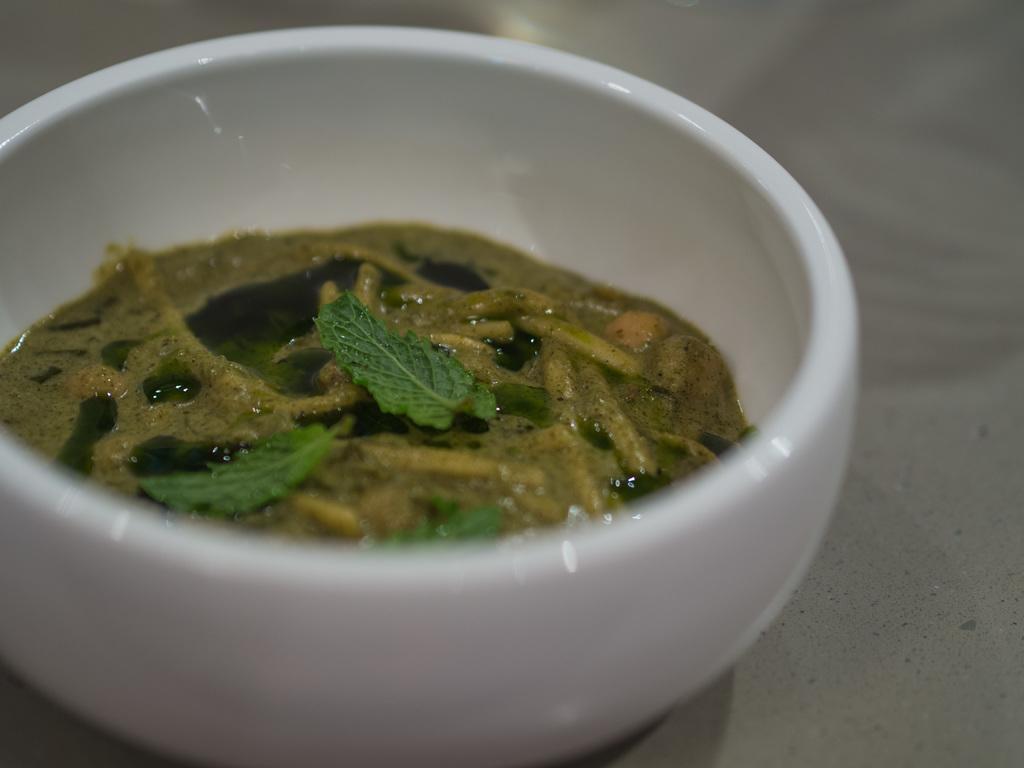In one or two sentences, can you explain what this image depicts? In this image, we can see soup in the bowl and at the bottom, there is a table. 